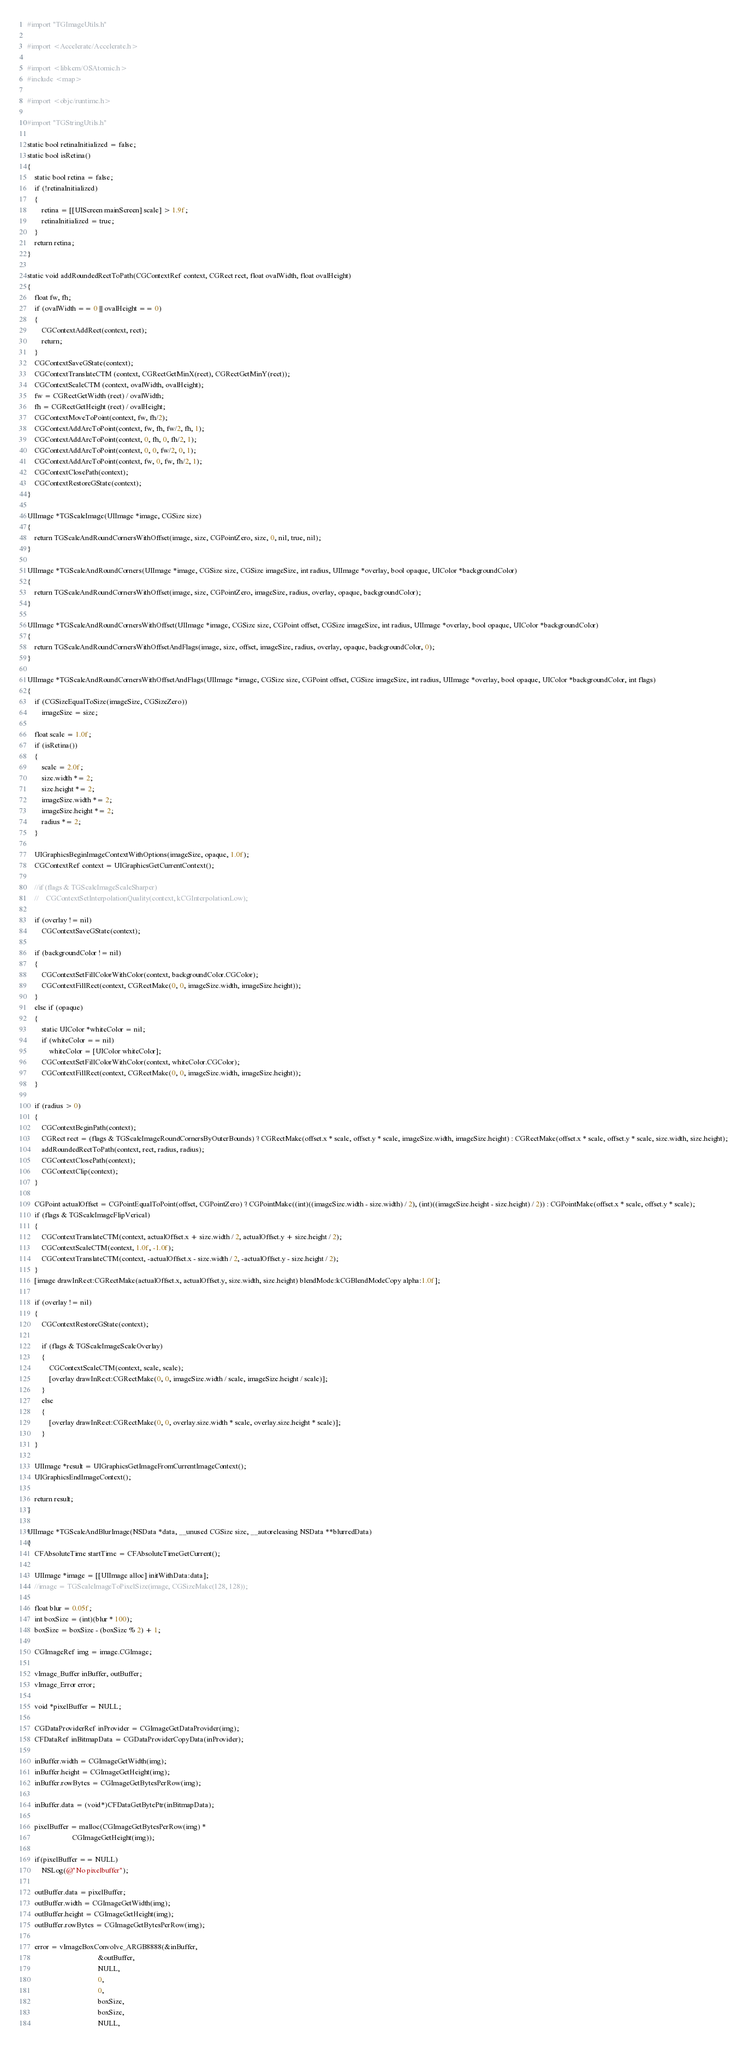<code> <loc_0><loc_0><loc_500><loc_500><_ObjectiveC_>#import "TGImageUtils.h"

#import <Accelerate/Accelerate.h>

#import <libkern/OSAtomic.h>
#include <map>

#import <objc/runtime.h>

#import "TGStringUtils.h"

static bool retinaInitialized = false;
static bool isRetina()
{
    static bool retina = false;
    if (!retinaInitialized)
    {
        retina = [[UIScreen mainScreen] scale] > 1.9f;
        retinaInitialized = true;
    }
    return retina;
}

static void addRoundedRectToPath(CGContextRef context, CGRect rect, float ovalWidth, float ovalHeight)
{
    float fw, fh;
    if (ovalWidth == 0 || ovalHeight == 0)
    {
        CGContextAddRect(context, rect);
        return;
    }
    CGContextSaveGState(context);
    CGContextTranslateCTM (context, CGRectGetMinX(rect), CGRectGetMinY(rect));
    CGContextScaleCTM (context, ovalWidth, ovalHeight);
    fw = CGRectGetWidth (rect) / ovalWidth;
    fh = CGRectGetHeight (rect) / ovalHeight;
    CGContextMoveToPoint(context, fw, fh/2);
    CGContextAddArcToPoint(context, fw, fh, fw/2, fh, 1);
    CGContextAddArcToPoint(context, 0, fh, 0, fh/2, 1);
    CGContextAddArcToPoint(context, 0, 0, fw/2, 0, 1);
    CGContextAddArcToPoint(context, fw, 0, fw, fh/2, 1);
    CGContextClosePath(context);
    CGContextRestoreGState(context);
}

UIImage *TGScaleImage(UIImage *image, CGSize size)
{
    return TGScaleAndRoundCornersWithOffset(image, size, CGPointZero, size, 0, nil, true, nil);
}

UIImage *TGScaleAndRoundCorners(UIImage *image, CGSize size, CGSize imageSize, int radius, UIImage *overlay, bool opaque, UIColor *backgroundColor)
{
    return TGScaleAndRoundCornersWithOffset(image, size, CGPointZero, imageSize, radius, overlay, opaque, backgroundColor);
}

UIImage *TGScaleAndRoundCornersWithOffset(UIImage *image, CGSize size, CGPoint offset, CGSize imageSize, int radius, UIImage *overlay, bool opaque, UIColor *backgroundColor)
{
    return TGScaleAndRoundCornersWithOffsetAndFlags(image, size, offset, imageSize, radius, overlay, opaque, backgroundColor, 0);
}

UIImage *TGScaleAndRoundCornersWithOffsetAndFlags(UIImage *image, CGSize size, CGPoint offset, CGSize imageSize, int radius, UIImage *overlay, bool opaque, UIColor *backgroundColor, int flags)
{
    if (CGSizeEqualToSize(imageSize, CGSizeZero))
        imageSize = size;
    
    float scale = 1.0f;
    if (isRetina())
    {
        scale = 2.0f;
        size.width *= 2;
        size.height *= 2;
        imageSize.width *= 2;
        imageSize.height *= 2;
        radius *= 2;
    }
    
    UIGraphicsBeginImageContextWithOptions(imageSize, opaque, 1.0f);
    CGContextRef context = UIGraphicsGetCurrentContext();
    
    //if (flags & TGScaleImageScaleSharper)
    //    CGContextSetInterpolationQuality(context, kCGInterpolationLow);
    
    if (overlay != nil)
        CGContextSaveGState(context);
    
    if (backgroundColor != nil)
    {
        CGContextSetFillColorWithColor(context, backgroundColor.CGColor);
        CGContextFillRect(context, CGRectMake(0, 0, imageSize.width, imageSize.height));
    }
    else if (opaque)
    {
        static UIColor *whiteColor = nil;
        if (whiteColor == nil)
            whiteColor = [UIColor whiteColor];
        CGContextSetFillColorWithColor(context, whiteColor.CGColor);
        CGContextFillRect(context, CGRectMake(0, 0, imageSize.width, imageSize.height));
    }
    
    if (radius > 0)
    {
        CGContextBeginPath(context);
        CGRect rect = (flags & TGScaleImageRoundCornersByOuterBounds) ? CGRectMake(offset.x * scale, offset.y * scale, imageSize.width, imageSize.height) : CGRectMake(offset.x * scale, offset.y * scale, size.width, size.height);
        addRoundedRectToPath(context, rect, radius, radius);
        CGContextClosePath(context);
        CGContextClip(context);
    }
    
    CGPoint actualOffset = CGPointEqualToPoint(offset, CGPointZero) ? CGPointMake((int)((imageSize.width - size.width) / 2), (int)((imageSize.height - size.height) / 2)) : CGPointMake(offset.x * scale, offset.y * scale);
    if (flags & TGScaleImageFlipVerical)
    {
        CGContextTranslateCTM(context, actualOffset.x + size.width / 2, actualOffset.y + size.height / 2);
        CGContextScaleCTM(context, 1.0f, -1.0f);
        CGContextTranslateCTM(context, -actualOffset.x - size.width / 2, -actualOffset.y - size.height / 2);
    }
    [image drawInRect:CGRectMake(actualOffset.x, actualOffset.y, size.width, size.height) blendMode:kCGBlendModeCopy alpha:1.0f];
    
    if (overlay != nil)
    {
        CGContextRestoreGState(context);
        
        if (flags & TGScaleImageScaleOverlay)
        {
            CGContextScaleCTM(context, scale, scale);
            [overlay drawInRect:CGRectMake(0, 0, imageSize.width / scale, imageSize.height / scale)];
        }
        else
        {
            [overlay drawInRect:CGRectMake(0, 0, overlay.size.width * scale, overlay.size.height * scale)];
        }
    }
    
    UIImage *result = UIGraphicsGetImageFromCurrentImageContext();
    UIGraphicsEndImageContext();
    
    return result;
}

UIImage *TGScaleAndBlurImage(NSData *data, __unused CGSize size, __autoreleasing NSData **blurredData)
{
    CFAbsoluteTime startTime = CFAbsoluteTimeGetCurrent();
    
    UIImage *image = [[UIImage alloc] initWithData:data];
    //image = TGScaleImageToPixelSize(image, CGSizeMake(128, 128));
    
    float blur = 0.05f;
    int boxSize = (int)(blur * 100);
    boxSize = boxSize - (boxSize % 2) + 1;
    
    CGImageRef img = image.CGImage;
    
    vImage_Buffer inBuffer, outBuffer;
    vImage_Error error;
    
    void *pixelBuffer = NULL;
    
    CGDataProviderRef inProvider = CGImageGetDataProvider(img);
    CFDataRef inBitmapData = CGDataProviderCopyData(inProvider);
    
    inBuffer.width = CGImageGetWidth(img);
    inBuffer.height = CGImageGetHeight(img);
    inBuffer.rowBytes = CGImageGetBytesPerRow(img);
    
    inBuffer.data = (void*)CFDataGetBytePtr(inBitmapData);
    
    pixelBuffer = malloc(CGImageGetBytesPerRow(img) *
                         CGImageGetHeight(img));
    
    if(pixelBuffer == NULL)
        NSLog(@"No pixelbuffer");
    
    outBuffer.data = pixelBuffer;
    outBuffer.width = CGImageGetWidth(img);
    outBuffer.height = CGImageGetHeight(img);
    outBuffer.rowBytes = CGImageGetBytesPerRow(img);
    
    error = vImageBoxConvolve_ARGB8888(&inBuffer,
                                       &outBuffer,
                                       NULL,
                                       0,
                                       0,
                                       boxSize,
                                       boxSize,
                                       NULL,</code> 